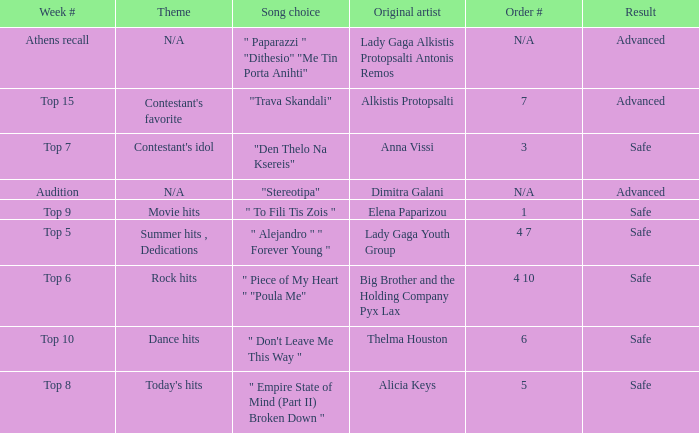What are all the order #s from the week "top 6"? 4 10. 